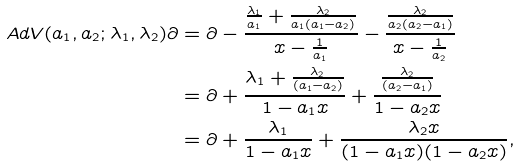Convert formula to latex. <formula><loc_0><loc_0><loc_500><loc_500>A d V ( a _ { 1 } , a _ { 2 } ; \lambda _ { 1 } , \lambda _ { 2 } ) \partial & = \partial - \frac { \frac { \lambda _ { 1 } } { a _ { 1 } } + \frac { \lambda _ { 2 } } { a _ { 1 } ( a _ { 1 } - a _ { 2 } ) } } { x - \frac { 1 } { a _ { 1 } } } - \frac { \frac { \lambda _ { 2 } } { a _ { 2 } ( a _ { 2 } - a _ { 1 } ) } } { x - \frac { 1 } { a _ { 2 } } } \\ & = \partial + \frac { \lambda _ { 1 } + \frac { \lambda _ { 2 } } { ( a _ { 1 } - a _ { 2 } ) } } { 1 - a _ { 1 } x } + \frac { \frac { \lambda _ { 2 } } { ( a _ { 2 } - a _ { 1 } ) } } { 1 - a _ { 2 } x } \\ & = \partial + \frac { \lambda _ { 1 } } { 1 - a _ { 1 } x } + \frac { \lambda _ { 2 } x } { ( 1 - a _ { 1 } x ) ( 1 - a _ { 2 } x ) } ,</formula> 